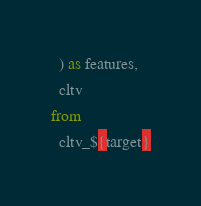Convert code to text. <code><loc_0><loc_0><loc_500><loc_500><_SQL_>  ) as features,
  cltv
from
  cltv_${target}
</code> 